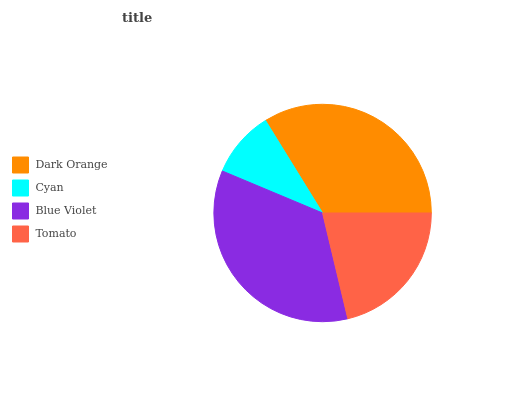Is Cyan the minimum?
Answer yes or no. Yes. Is Blue Violet the maximum?
Answer yes or no. Yes. Is Blue Violet the minimum?
Answer yes or no. No. Is Cyan the maximum?
Answer yes or no. No. Is Blue Violet greater than Cyan?
Answer yes or no. Yes. Is Cyan less than Blue Violet?
Answer yes or no. Yes. Is Cyan greater than Blue Violet?
Answer yes or no. No. Is Blue Violet less than Cyan?
Answer yes or no. No. Is Dark Orange the high median?
Answer yes or no. Yes. Is Tomato the low median?
Answer yes or no. Yes. Is Tomato the high median?
Answer yes or no. No. Is Dark Orange the low median?
Answer yes or no. No. 